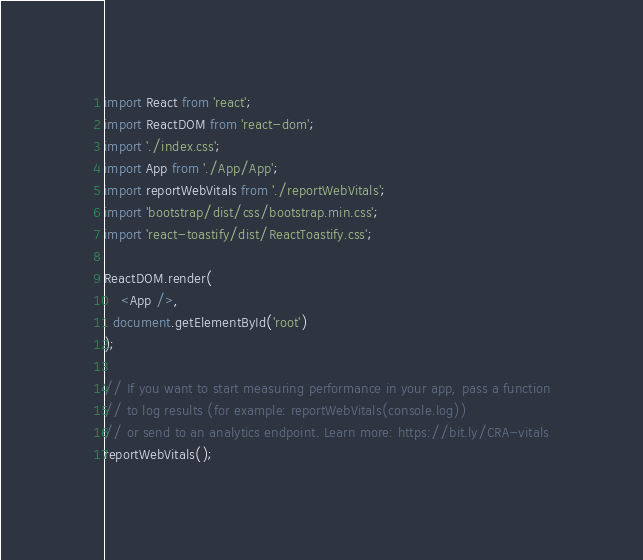Convert code to text. <code><loc_0><loc_0><loc_500><loc_500><_JavaScript_>import React from 'react';
import ReactDOM from 'react-dom';
import './index.css';
import App from './App/App';
import reportWebVitals from './reportWebVitals';
import 'bootstrap/dist/css/bootstrap.min.css';
import 'react-toastify/dist/ReactToastify.css';

ReactDOM.render(
    <App />,
  document.getElementById('root')
);

// If you want to start measuring performance in your app, pass a function
// to log results (for example: reportWebVitals(console.log))
// or send to an analytics endpoint. Learn more: https://bit.ly/CRA-vitals
reportWebVitals();
</code> 